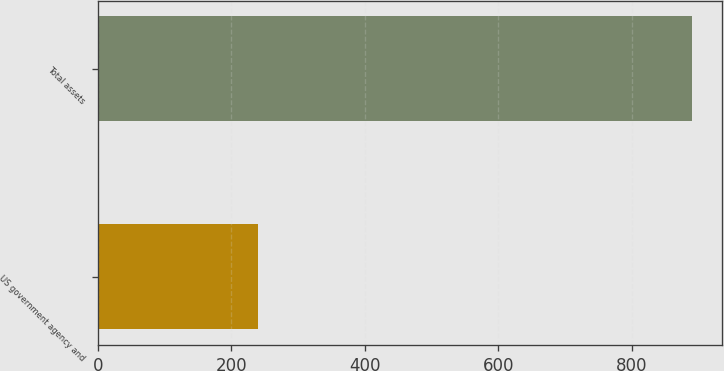<chart> <loc_0><loc_0><loc_500><loc_500><bar_chart><fcel>US government agency and<fcel>Total assets<nl><fcel>240<fcel>891<nl></chart> 